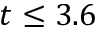<formula> <loc_0><loc_0><loc_500><loc_500>t \leq 3 . 6</formula> 